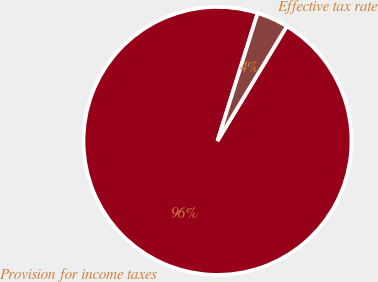<chart> <loc_0><loc_0><loc_500><loc_500><pie_chart><fcel>Provision for income taxes<fcel>Effective tax rate<nl><fcel>96.19%<fcel>3.81%<nl></chart> 